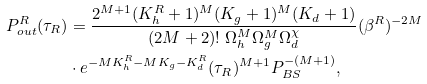<formula> <loc_0><loc_0><loc_500><loc_500>P ^ { R } _ { o u t } ( \tau _ { R } ) & = \frac { 2 ^ { M + 1 } ( K ^ { R } _ { h } + 1 ) ^ { M } ( K _ { g } + 1 ) ^ { M } ( K _ { d } + 1 ) } { ( 2 M + 2 ) ! \ \Omega _ { h } ^ { M } \Omega ^ { M } _ { g } \Omega ^ { \chi } _ { d } } ( \beta ^ { R } ) ^ { - 2 M } \\ & \cdot e ^ { - M K ^ { R } _ { h } - M K _ { g } - K ^ { R } _ { d } } ( \tau _ { R } ) ^ { M + 1 } P _ { B S } ^ { - ( M + 1 ) } ,</formula> 